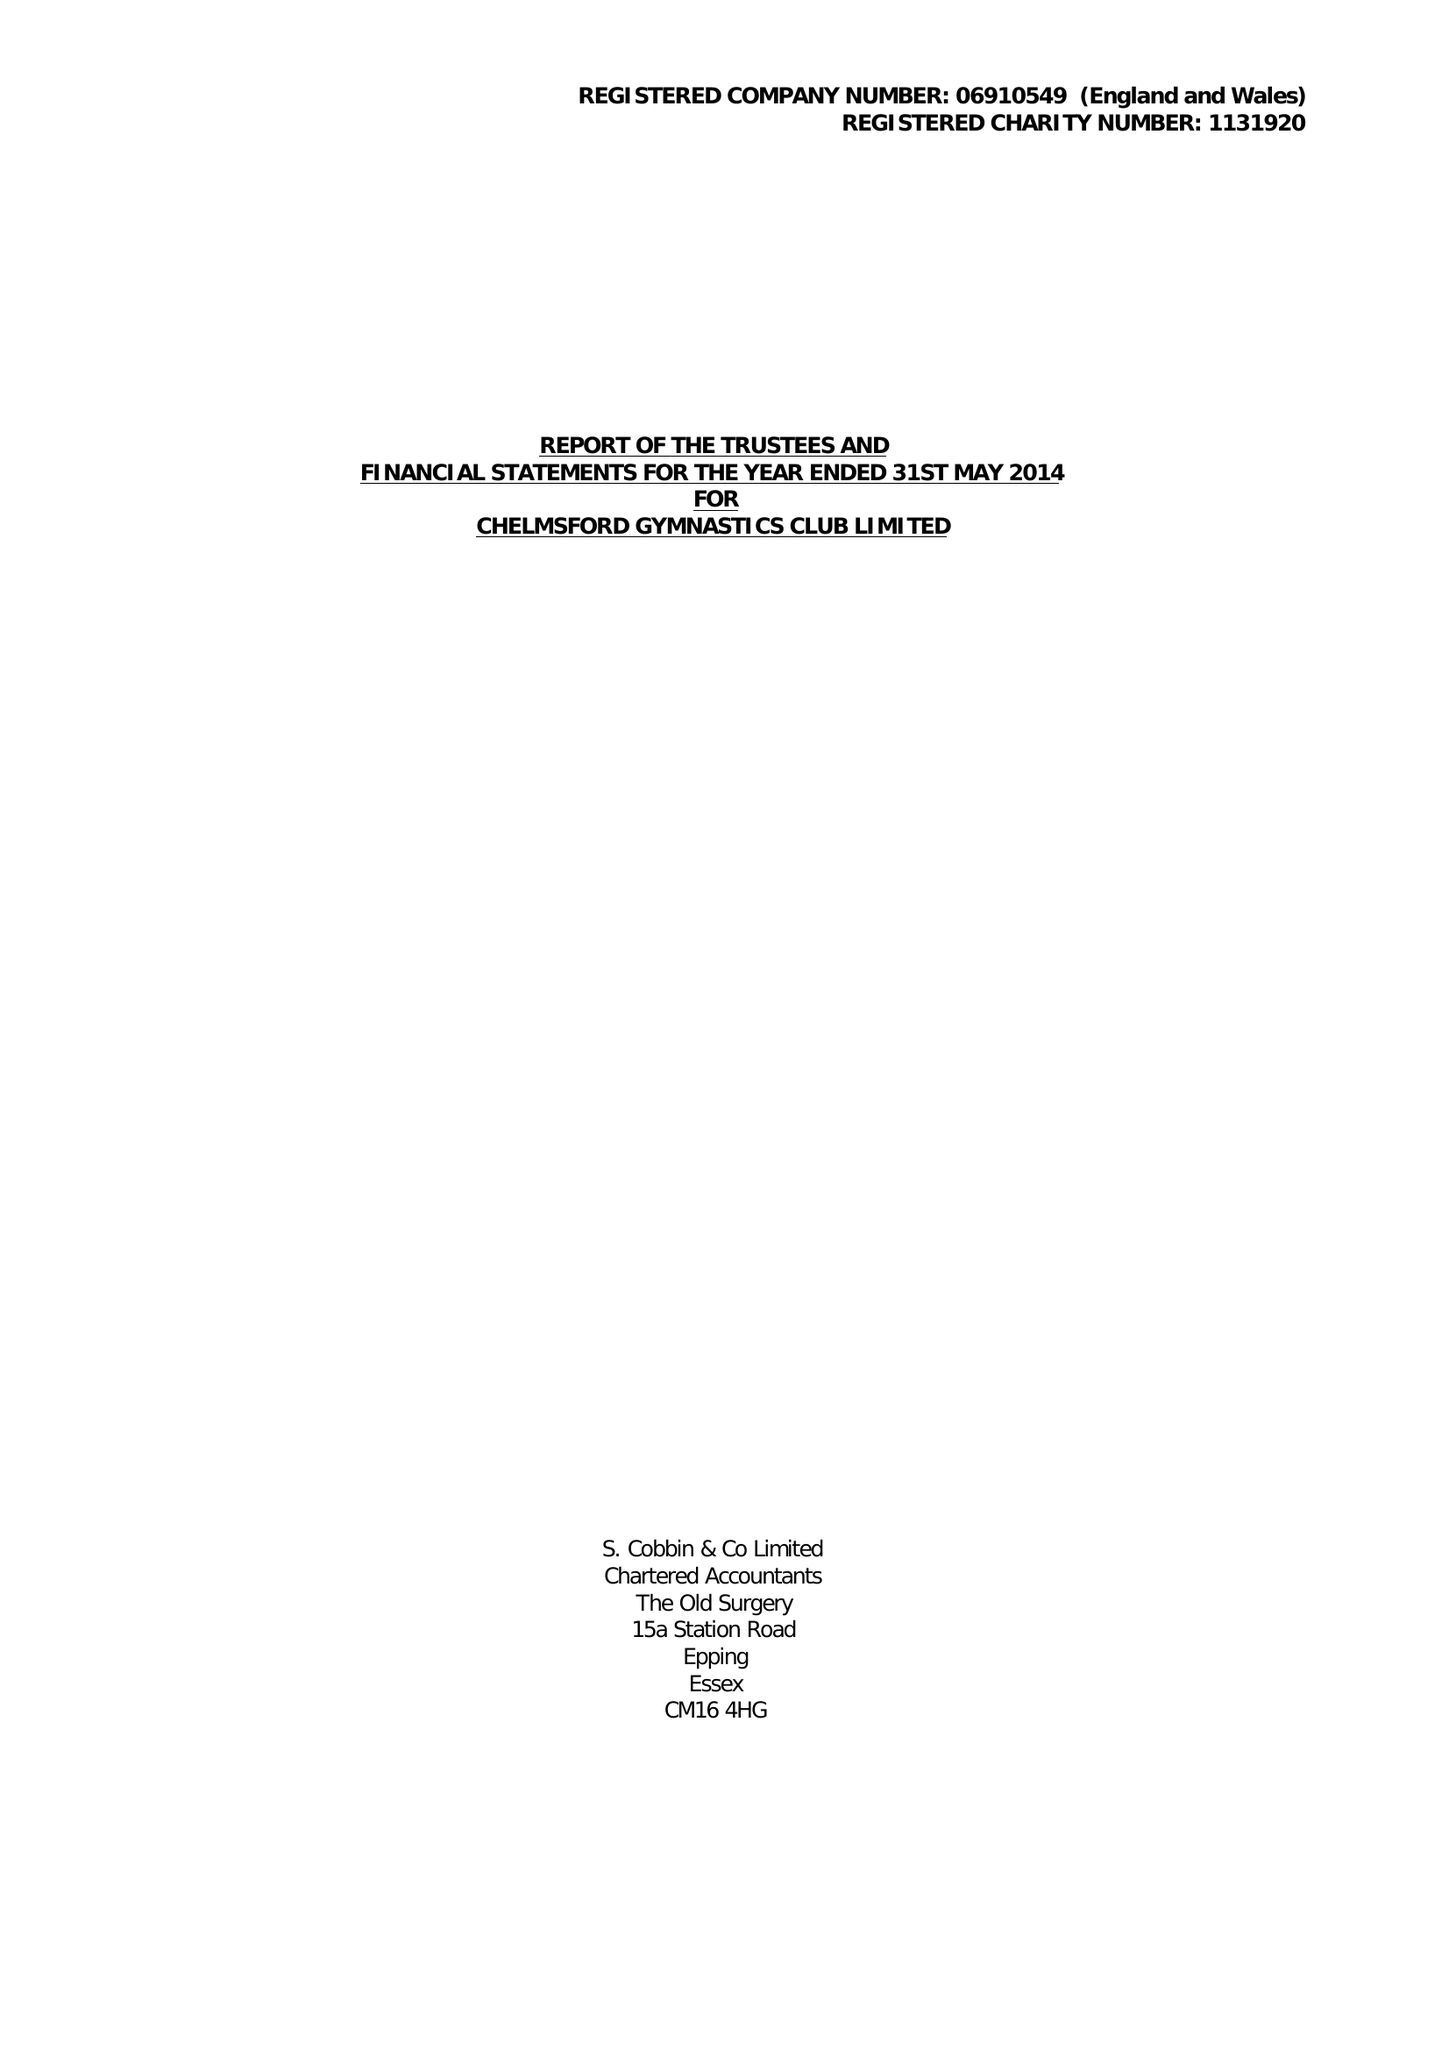What is the value for the address__street_line?
Answer the question using a single word or phrase. 9 THE HEYTHROP 